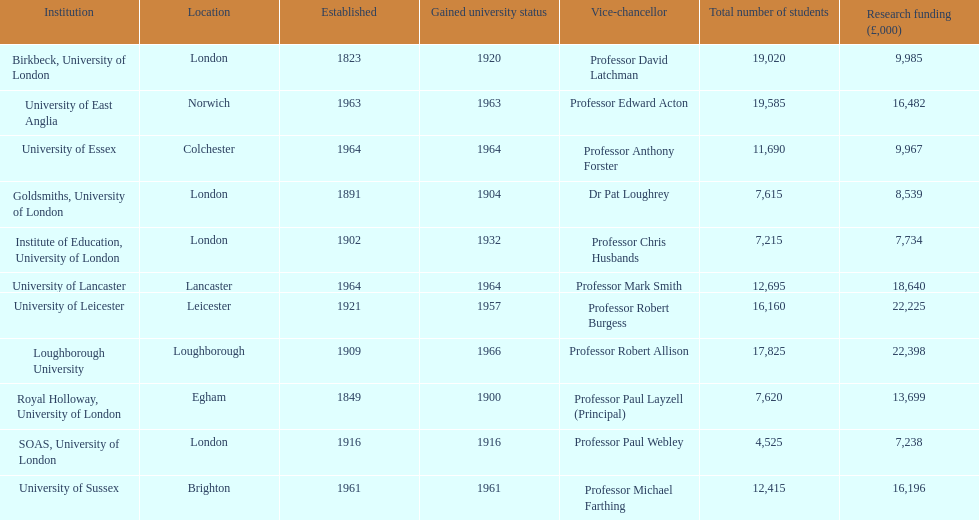Which institution is awarded the most financial support for conducting research? Loughborough University. 